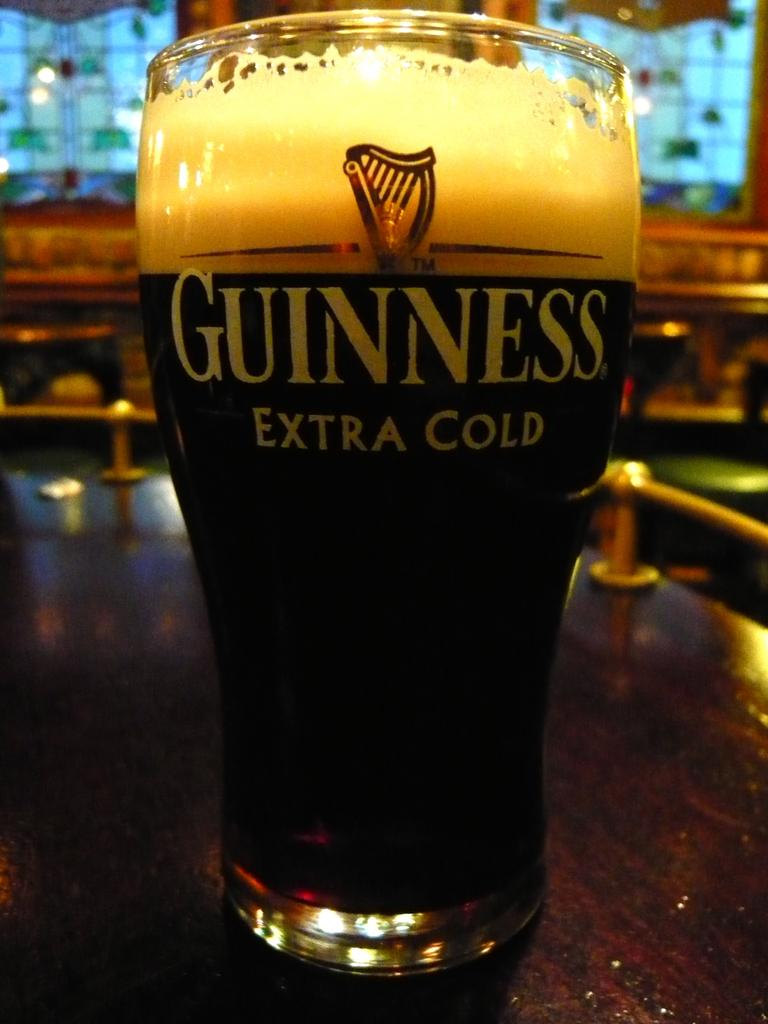<image>
Describe the image concisely. A glass full of liquid has the brand Guiness printed on it. 